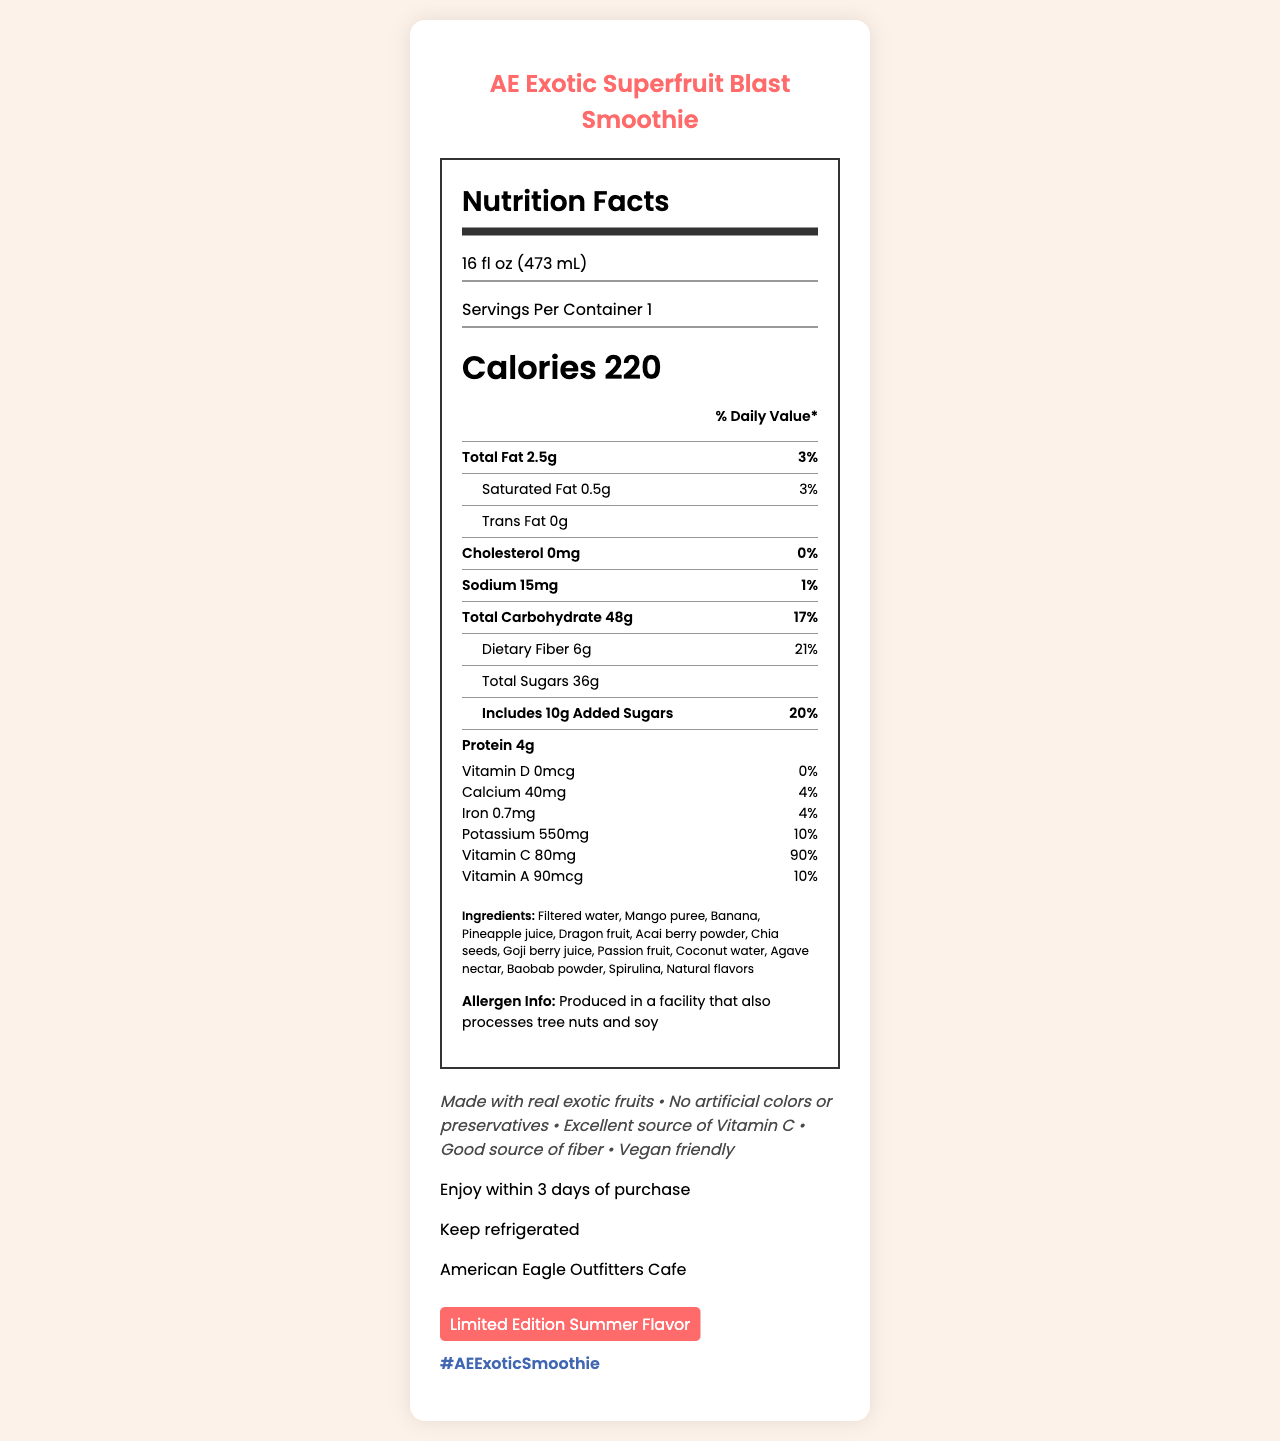what is the serving size for the AE Exotic Superfruit Blast Smoothie? The serving size is directly listed on the document as 16 fl oz (473 mL).
Answer: 16 fl oz (473 mL) how many calories are in one serving of the smoothie? The document states that there are 220 calories in one serving.
Answer: 220 calories what percentage of the daily value of dietary fiber is in one serving? The nutritional label shows that one serving provides 21% of the daily value of dietary fiber.
Answer: 21% what are the first three ingredients listed for the smoothie? The ingredients are listed in order with the first three being Filtered water, Mango puree, and Banana.
Answer: Filtered water, Mango puree, Banana how much vitamin C does one serving contain? The nutritional label details that one serving contains 80mg of vitamin C.
Answer: 80mg how much total fat is in the smoothie? The document shows that there is a total of 2.5g of fat in one serving.
Answer: 2.5g what is the best before date for the AE Exotic Superfruit Blast Smoothie? The document states that the smoothie should be enjoyed within 3 days of purchase.
Answer: Enjoy within 3 days of purchase Which of the following is true about the smoothie? 
A. It contains soy.
B. It's vegan friendly.
C. It contains artificial colors. The marketing claims mention that the smoothie is vegan friendly.
Answer: B what is the correct percentage daily value of calcium in the smoothie? 
A. 10%
B. 20%
C. 4%
D. 15% The document specifies that the smoothie has 4% of the daily value of calcium.
Answer: C Does the smoothie contain any artificial preservatives? The marketing claims state that the product has no artificial colors or preservatives.
Answer: No is this smoothie part of the regular lineup of products? The document mentions it is a limited edition summer flavor.
Answer: No describe the main idea of the document. The document outlines the nutritional value, ingredients, storage instructions, and marketing highlights of the AE Exotic Superfruit Blast Smoothie, emphasizing its exotic fruits, lack of artificial preservatives, and limited-edition status.
Answer: The main idea is to provide detailed nutritional information about the AE Exotic Superfruit Blast Smoothie, including serving size, calorie count, contents of various nutrients, ingredients, allergen info, and special marketing claims highlighting its attributes, such as being vegan friendly and high in vitamin C. how many grams of protein does the smoothie contain? The document lists that the smoothie has 4g of protein per serving.
Answer: 4g what is the percentage daily value of potassium in one serving? The nutritional information states that one serving contains 10% of the daily value for potassium.
Answer: 10% what is the main flavor element of the smoothie? The document does not provide enough information to determine the main flavor element of the smoothie. It only lists various exotic fruits.
Answer: Cannot be determined to which social media hashtag should you refer when posting about the smoothie? The document mentions that the social media hashtag for the smoothie is #AEExoticSmoothie.
Answer: #AEExoticSmoothie 